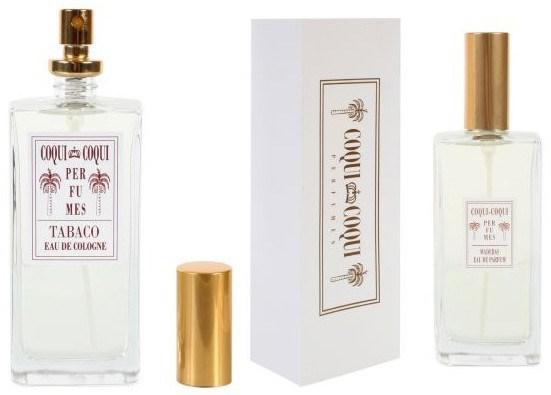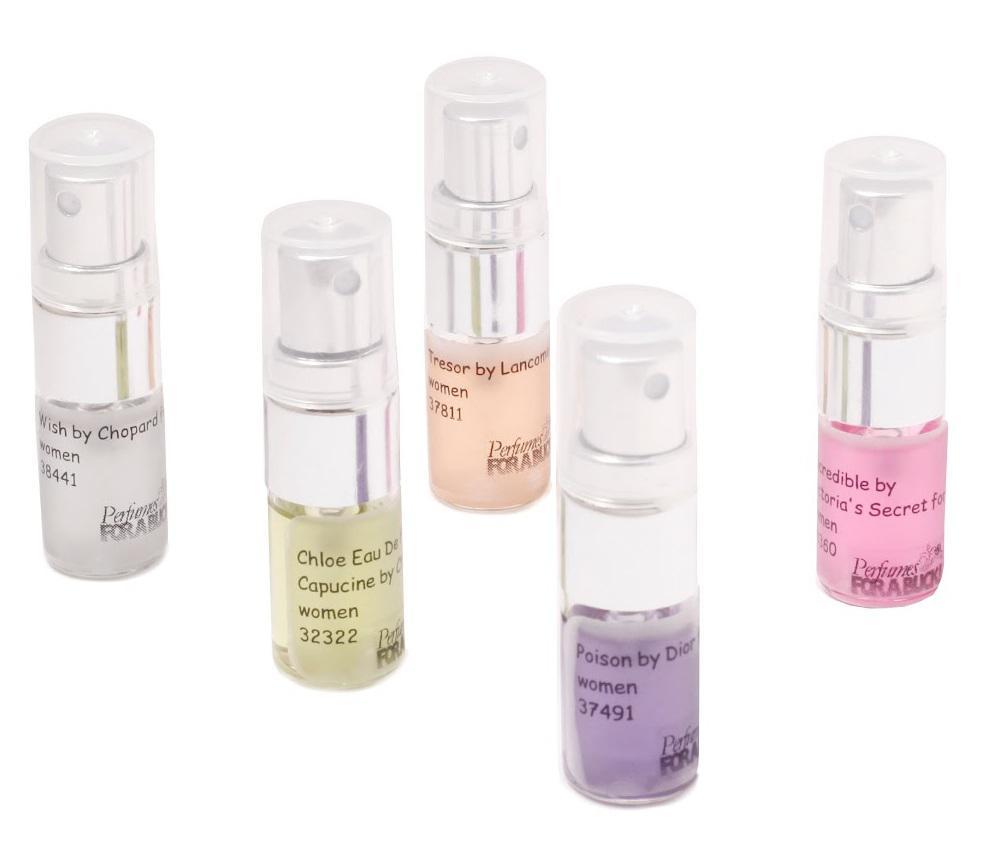The first image is the image on the left, the second image is the image on the right. Assess this claim about the two images: "There are at least five bottles of perfume with one square bottle that has a red top with a gold stripe.". Correct or not? Answer yes or no. No. The first image is the image on the left, the second image is the image on the right. Examine the images to the left and right. Is the description "None of the fragrances are seen with their box." accurate? Answer yes or no. No. 